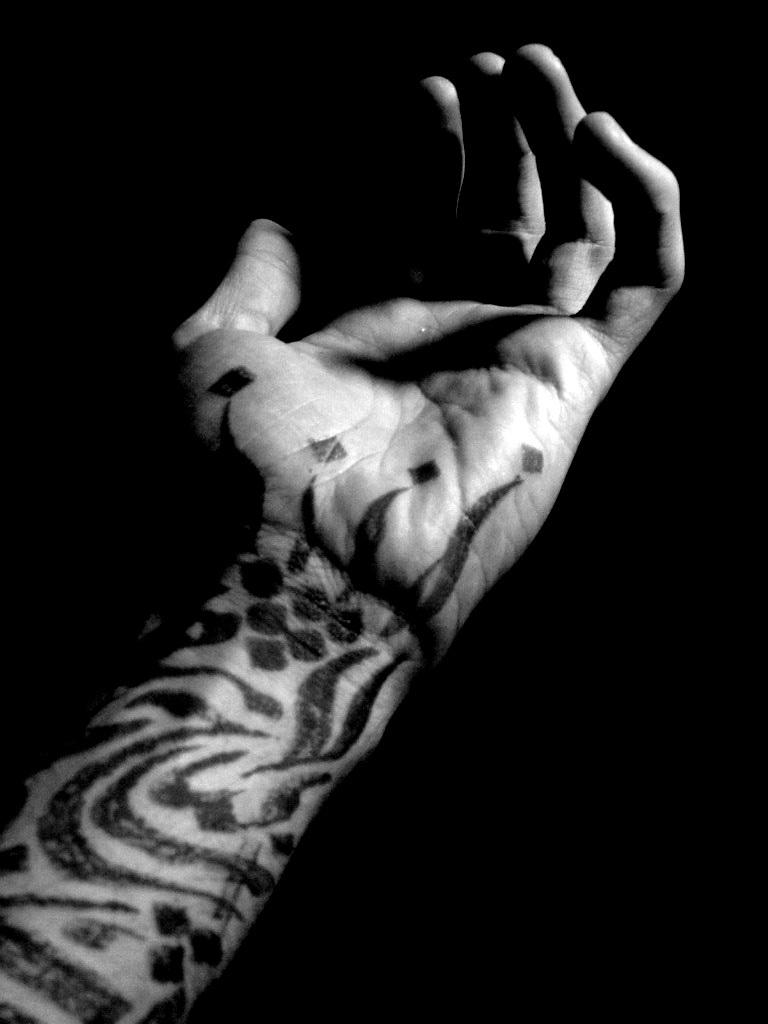What is the main subject in the foreground of the image? There is a person's hand in the foreground of the image. What can be observed about the background of the image? The background of the image is dark. What type of suit is the person wearing in the image? There is no suit visible in the image, as only a person's hand is shown. Can you tell me how many items are in the person's pocket in the image? There is no information about a pocket or any items in it, as only a person's hand is shown in the image. 